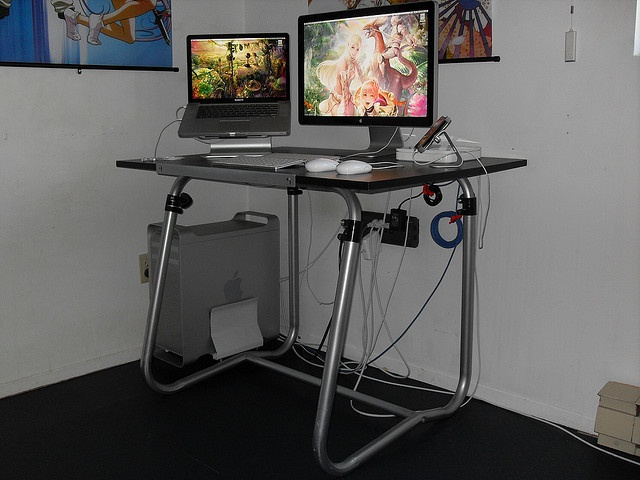Describe the objects in this image and their specific colors. I can see tv in gray, black, lightgray, and tan tones, laptop in gray, black, olive, and tan tones, keyboard in gray and black tones, keyboard in gray and black tones, and cell phone in gray, black, maroon, and darkgray tones in this image. 